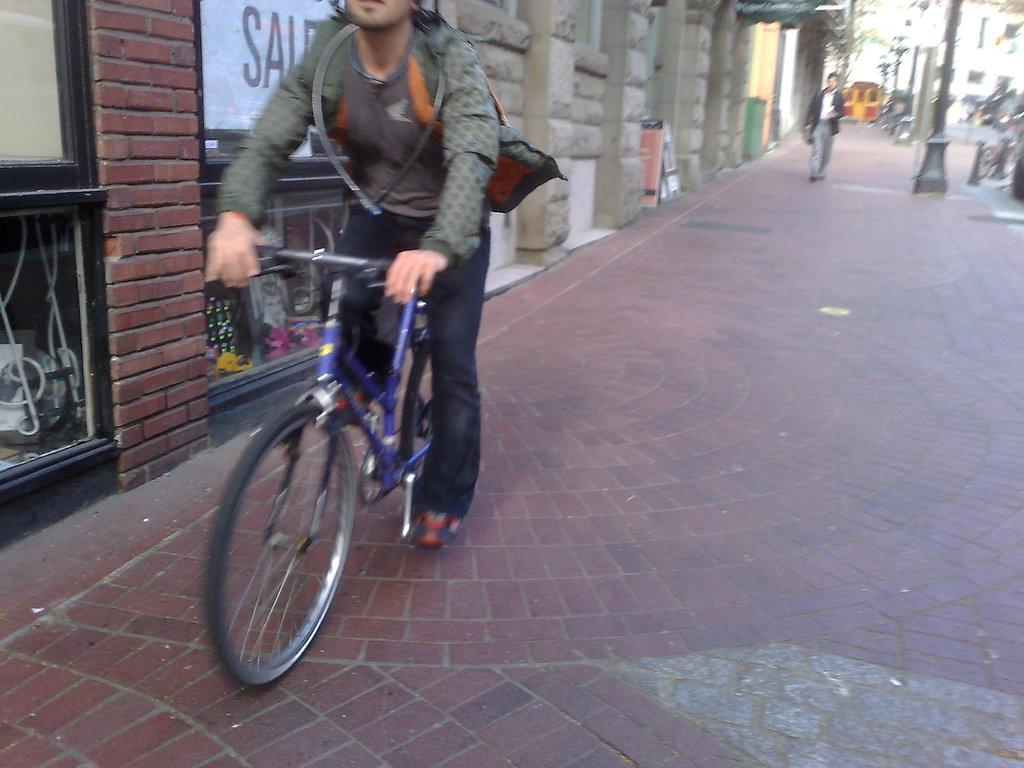What is the main subject of the image? There is a person riding a bicycle in the image. Can you describe the secondary activity happening in the background? There is a person walking on the sidewalk in the background of the image. What can be seen in the distance behind the main subject? Buildings, electric poles, and trees are visible in the background of the image. What type of butter is being used to iron the person's clothes in the image? There is no butter or ironing activity present in the image. 